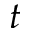<formula> <loc_0><loc_0><loc_500><loc_500>t</formula> 